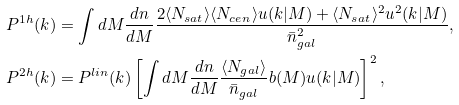Convert formula to latex. <formula><loc_0><loc_0><loc_500><loc_500>P ^ { 1 h } ( k ) & = \int d M \frac { d n } { d M } \frac { 2 \langle N _ { s a t } \rangle \langle N _ { c e n } \rangle u ( k | M ) + \langle N _ { s a t } \rangle ^ { 2 } u ^ { 2 } ( k | M ) } { \bar { n } _ { g a l } ^ { 2 } } , \\ P ^ { 2 h } ( k ) & = P ^ { l i n } ( k ) \left [ \int d M \frac { d n } { d M } \frac { \langle N _ { g a l } \rangle } { \bar { n } _ { g a l } } b ( M ) u ( k | M ) \right ] ^ { 2 } ,</formula> 